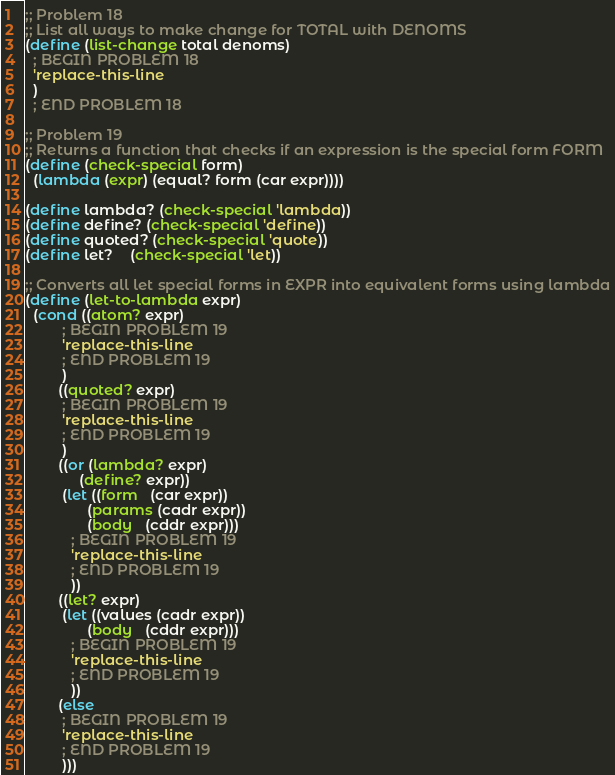Convert code to text. <code><loc_0><loc_0><loc_500><loc_500><_Scheme_>;; Problem 18
;; List all ways to make change for TOTAL with DENOMS
(define (list-change total denoms)
  ; BEGIN PROBLEM 18
  'replace-this-line
  )
  ; END PROBLEM 18

;; Problem 19
;; Returns a function that checks if an expression is the special form FORM
(define (check-special form)
  (lambda (expr) (equal? form (car expr))))

(define lambda? (check-special 'lambda))
(define define? (check-special 'define))
(define quoted? (check-special 'quote))
(define let?    (check-special 'let))

;; Converts all let special forms in EXPR into equivalent forms using lambda
(define (let-to-lambda expr)
  (cond ((atom? expr)
         ; BEGIN PROBLEM 19
         'replace-this-line
         ; END PROBLEM 19
         )
        ((quoted? expr)
         ; BEGIN PROBLEM 19
         'replace-this-line
         ; END PROBLEM 19
         )
        ((or (lambda? expr)
             (define? expr))
         (let ((form   (car expr))
               (params (cadr expr))
               (body   (cddr expr)))
           ; BEGIN PROBLEM 19
           'replace-this-line
           ; END PROBLEM 19
           ))
        ((let? expr)
         (let ((values (cadr expr))
               (body   (cddr expr)))
           ; BEGIN PROBLEM 19
           'replace-this-line
           ; END PROBLEM 19
           ))
        (else
         ; BEGIN PROBLEM 19
         'replace-this-line
         ; END PROBLEM 19
         )))
</code> 